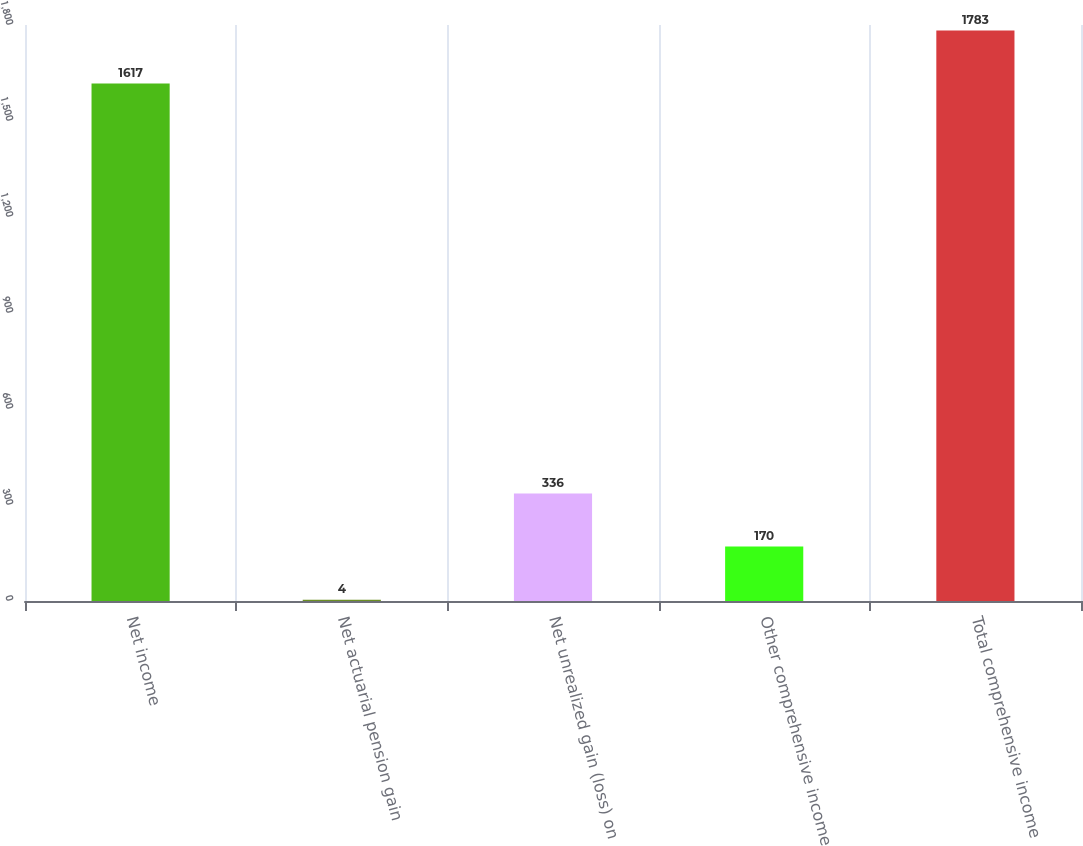<chart> <loc_0><loc_0><loc_500><loc_500><bar_chart><fcel>Net income<fcel>Net actuarial pension gain<fcel>Net unrealized gain (loss) on<fcel>Other comprehensive income<fcel>Total comprehensive income<nl><fcel>1617<fcel>4<fcel>336<fcel>170<fcel>1783<nl></chart> 